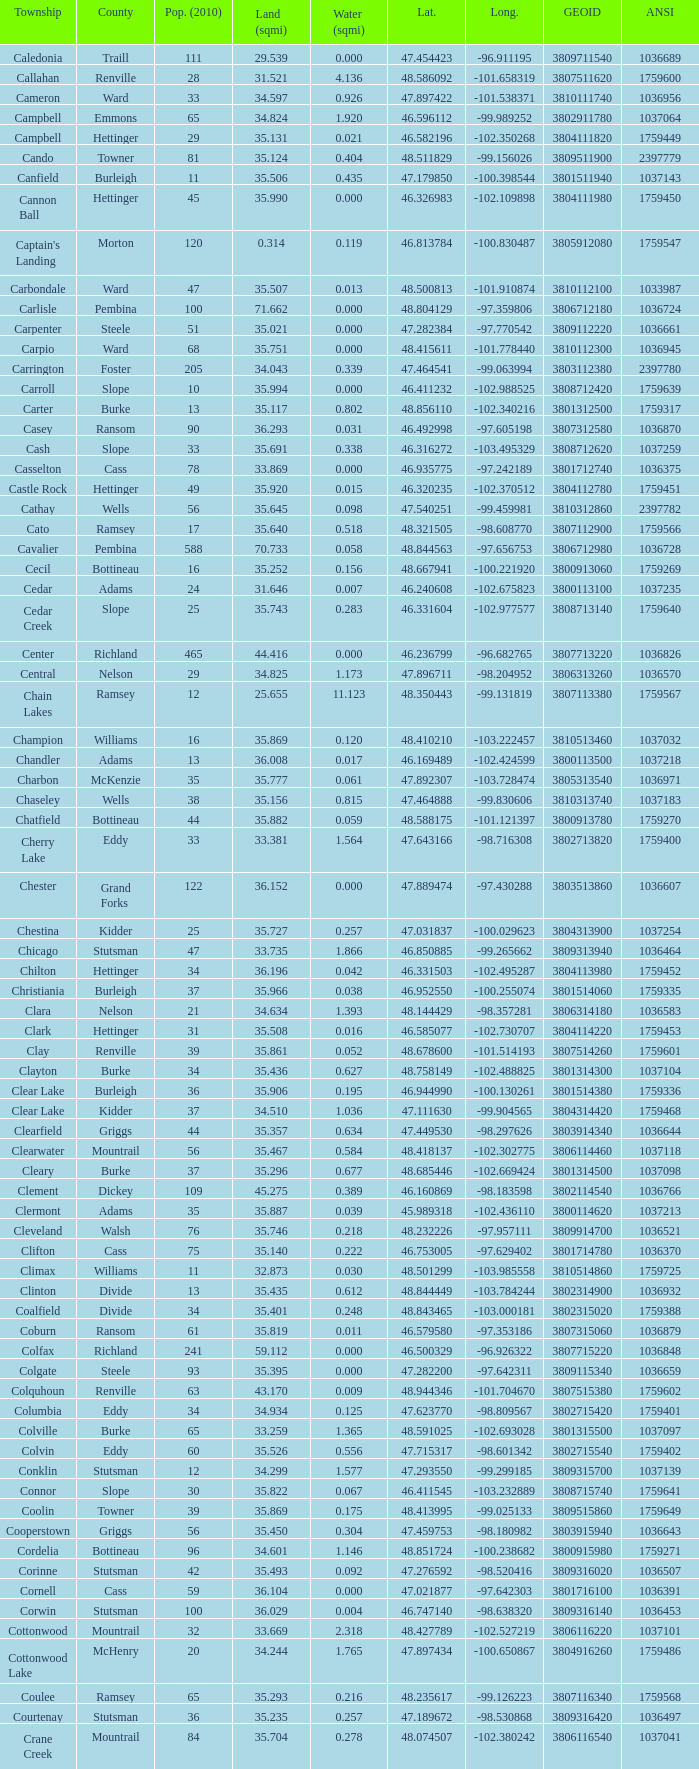What was the township with a geo ID of 3807116660? Creel. 